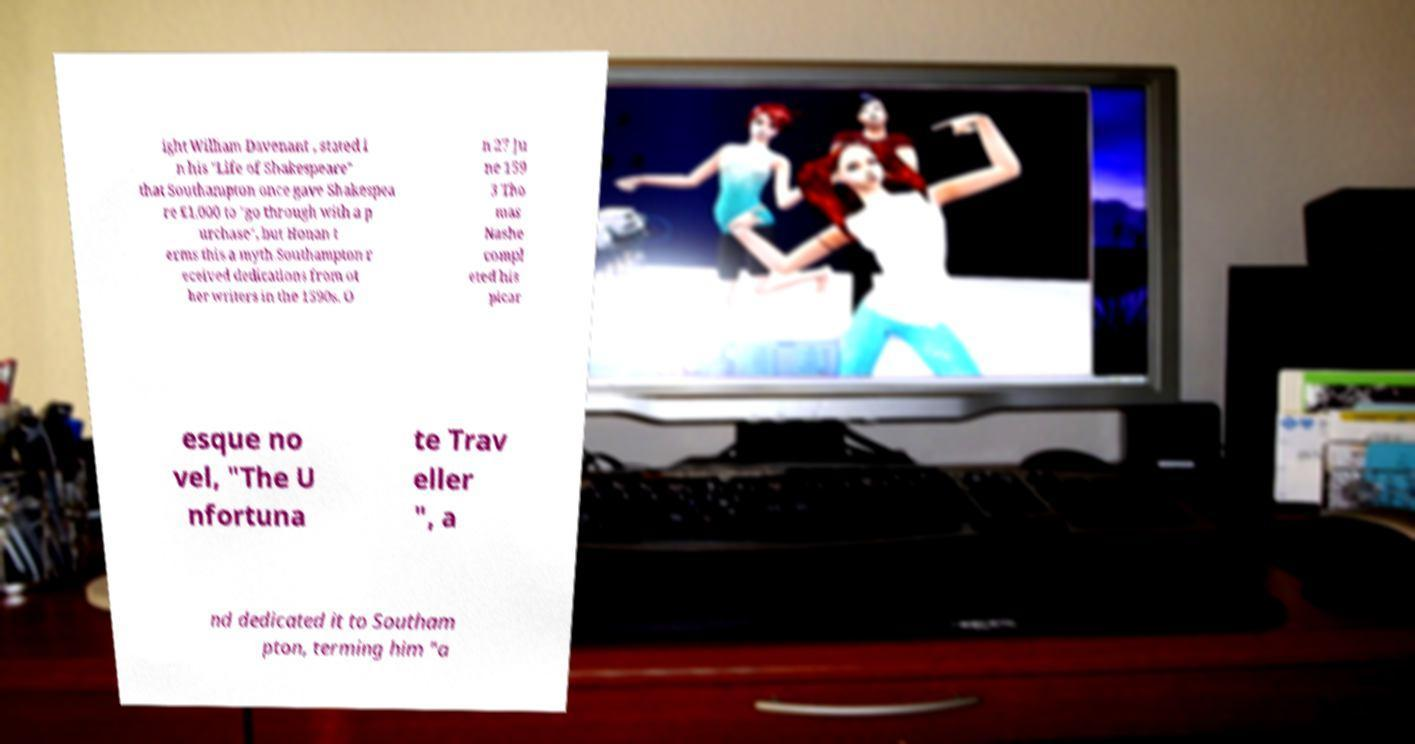I need the written content from this picture converted into text. Can you do that? ight William Davenant , stated i n his "Life of Shakespeare" that Southampton once gave Shakespea re £1,000 to "go through with a p urchase", but Honan t erms this a myth.Southampton r eceived dedications from ot her writers in the 1590s. O n 27 Ju ne 159 3 Tho mas Nashe compl eted his picar esque no vel, "The U nfortuna te Trav eller ", a nd dedicated it to Southam pton, terming him "a 